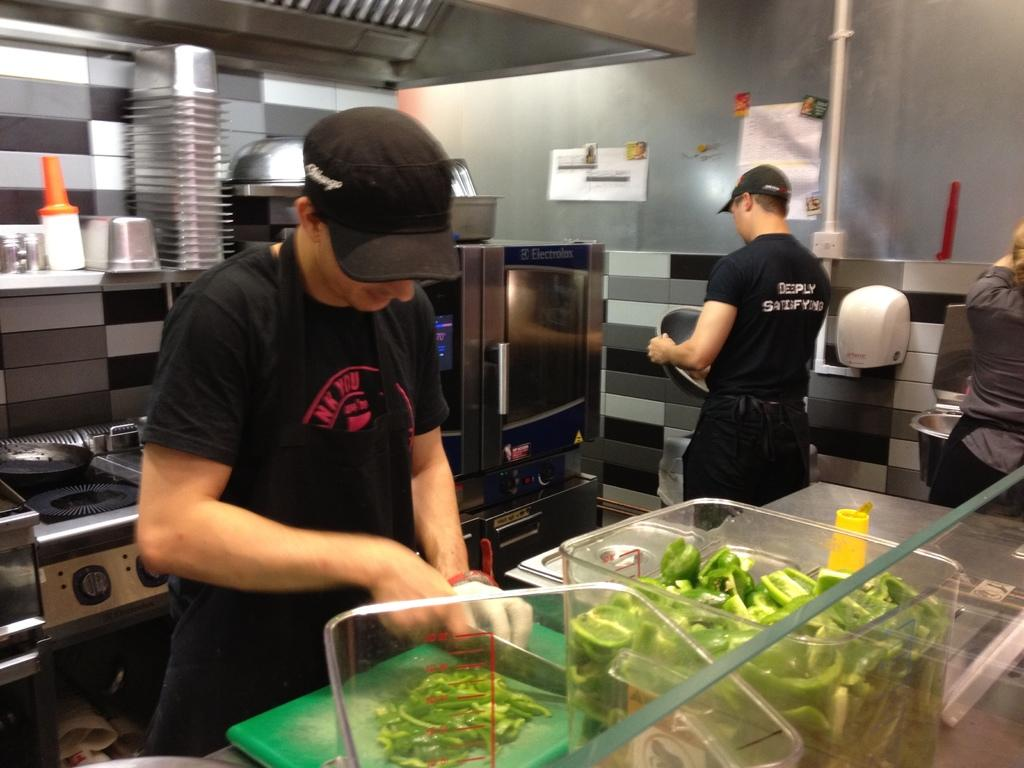Provide a one-sentence caption for the provided image. A man wearing a black shirt that says deeply satisfying on the back prepares to retrieve food from the microwave. 